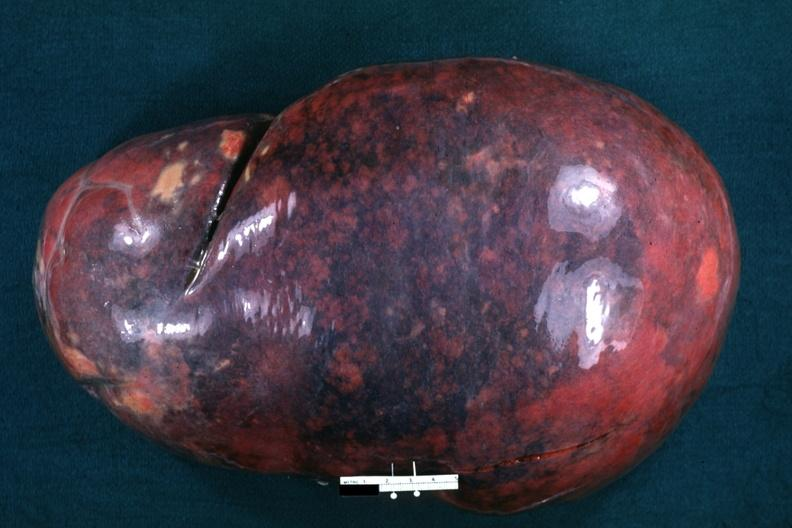does this image show whole spleen massively enlarged?
Answer the question using a single word or phrase. Yes 